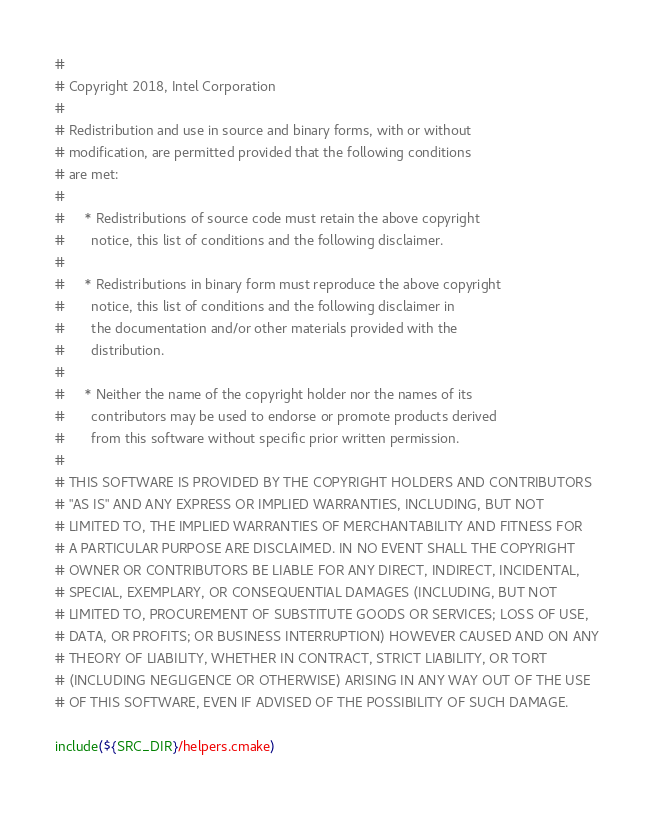Convert code to text. <code><loc_0><loc_0><loc_500><loc_500><_CMake_>#
# Copyright 2018, Intel Corporation
#
# Redistribution and use in source and binary forms, with or without
# modification, are permitted provided that the following conditions
# are met:
#
#     * Redistributions of source code must retain the above copyright
#       notice, this list of conditions and the following disclaimer.
#
#     * Redistributions in binary form must reproduce the above copyright
#       notice, this list of conditions and the following disclaimer in
#       the documentation and/or other materials provided with the
#       distribution.
#
#     * Neither the name of the copyright holder nor the names of its
#       contributors may be used to endorse or promote products derived
#       from this software without specific prior written permission.
#
# THIS SOFTWARE IS PROVIDED BY THE COPYRIGHT HOLDERS AND CONTRIBUTORS
# "AS IS" AND ANY EXPRESS OR IMPLIED WARRANTIES, INCLUDING, BUT NOT
# LIMITED TO, THE IMPLIED WARRANTIES OF MERCHANTABILITY AND FITNESS FOR
# A PARTICULAR PURPOSE ARE DISCLAIMED. IN NO EVENT SHALL THE COPYRIGHT
# OWNER OR CONTRIBUTORS BE LIABLE FOR ANY DIRECT, INDIRECT, INCIDENTAL,
# SPECIAL, EXEMPLARY, OR CONSEQUENTIAL DAMAGES (INCLUDING, BUT NOT
# LIMITED TO, PROCUREMENT OF SUBSTITUTE GOODS OR SERVICES; LOSS OF USE,
# DATA, OR PROFITS; OR BUSINESS INTERRUPTION) HOWEVER CAUSED AND ON ANY
# THEORY OF LIABILITY, WHETHER IN CONTRACT, STRICT LIABILITY, OR TORT
# (INCLUDING NEGLIGENCE OR OTHERWISE) ARISING IN ANY WAY OUT OF THE USE
# OF THIS SOFTWARE, EVEN IF ADVISED OF THE POSSIBILITY OF SUCH DAMAGE.

include(${SRC_DIR}/helpers.cmake)
</code> 